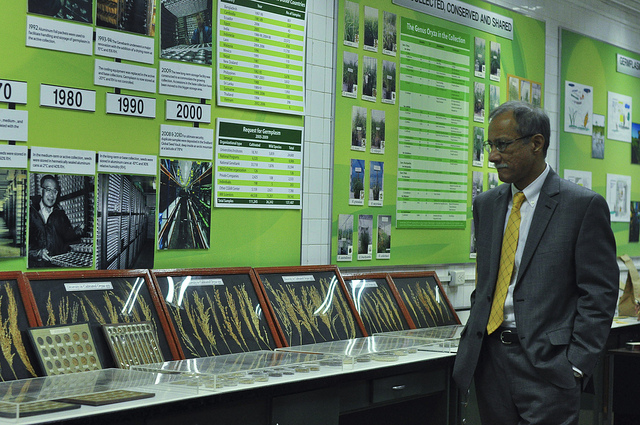Extract all visible text content from this image. 0 1980 1990 2000 CONSERVED 